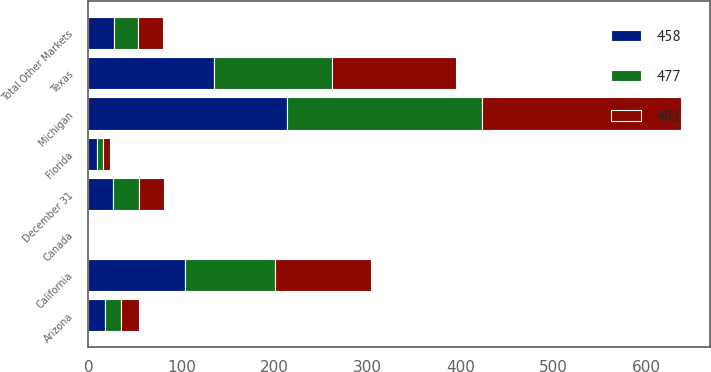<chart> <loc_0><loc_0><loc_500><loc_500><stacked_bar_chart><ecel><fcel>December 31<fcel>Michigan<fcel>Texas<fcel>California<fcel>Arizona<fcel>Florida<fcel>Canada<fcel>Total Other Markets<nl><fcel>477<fcel>27<fcel>209<fcel>127<fcel>97<fcel>17<fcel>7<fcel>1<fcel>25<nl><fcel>481<fcel>27<fcel>214<fcel>133<fcel>103<fcel>19<fcel>7<fcel>1<fcel>27<nl><fcel>458<fcel>27<fcel>214<fcel>135<fcel>104<fcel>18<fcel>9<fcel>1<fcel>28<nl></chart> 